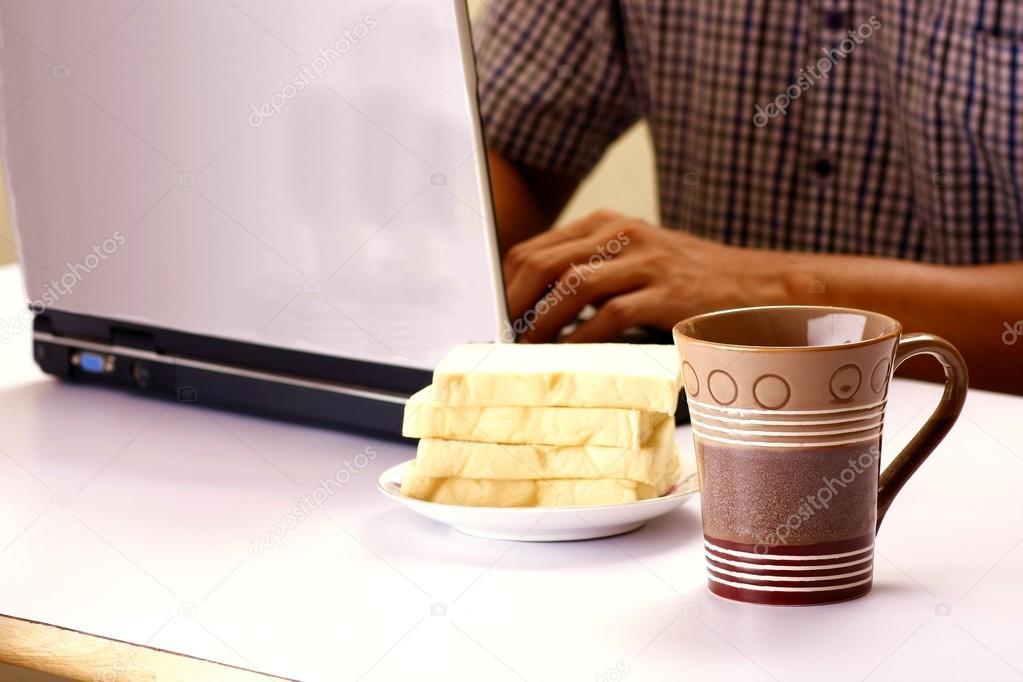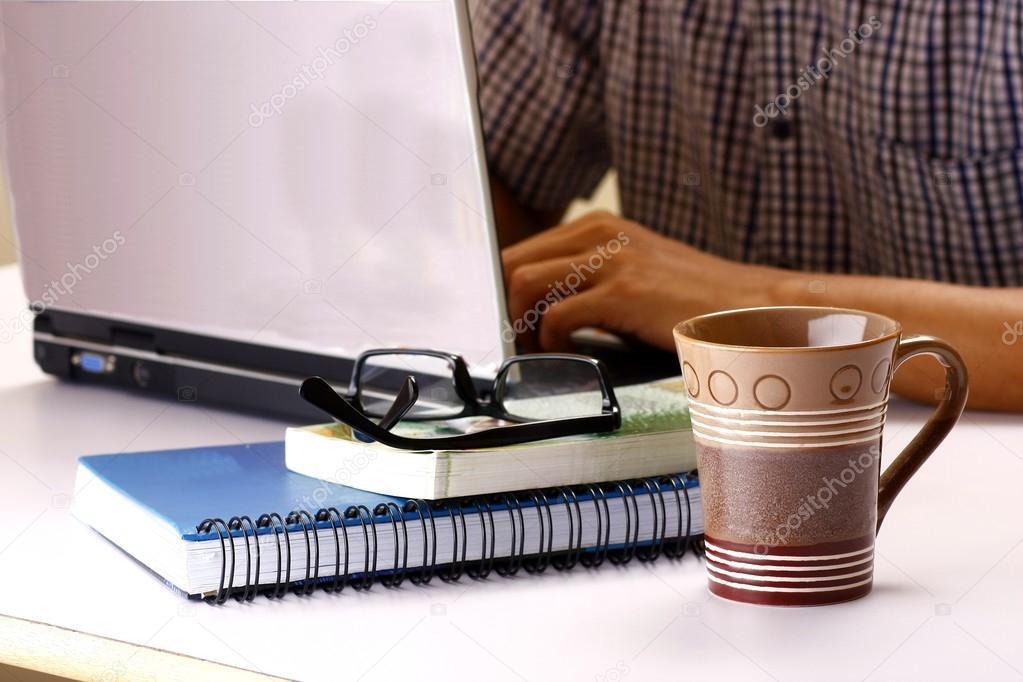The first image is the image on the left, the second image is the image on the right. Assess this claim about the two images: "There is one cup in the right image.". Correct or not? Answer yes or no. Yes. The first image is the image on the left, the second image is the image on the right. Given the left and right images, does the statement "A pen is on flat paper by a laptop screen and stacked paper materials in the right image, and the left image includes at least one hand on the base of an open laptop." hold true? Answer yes or no. No. 